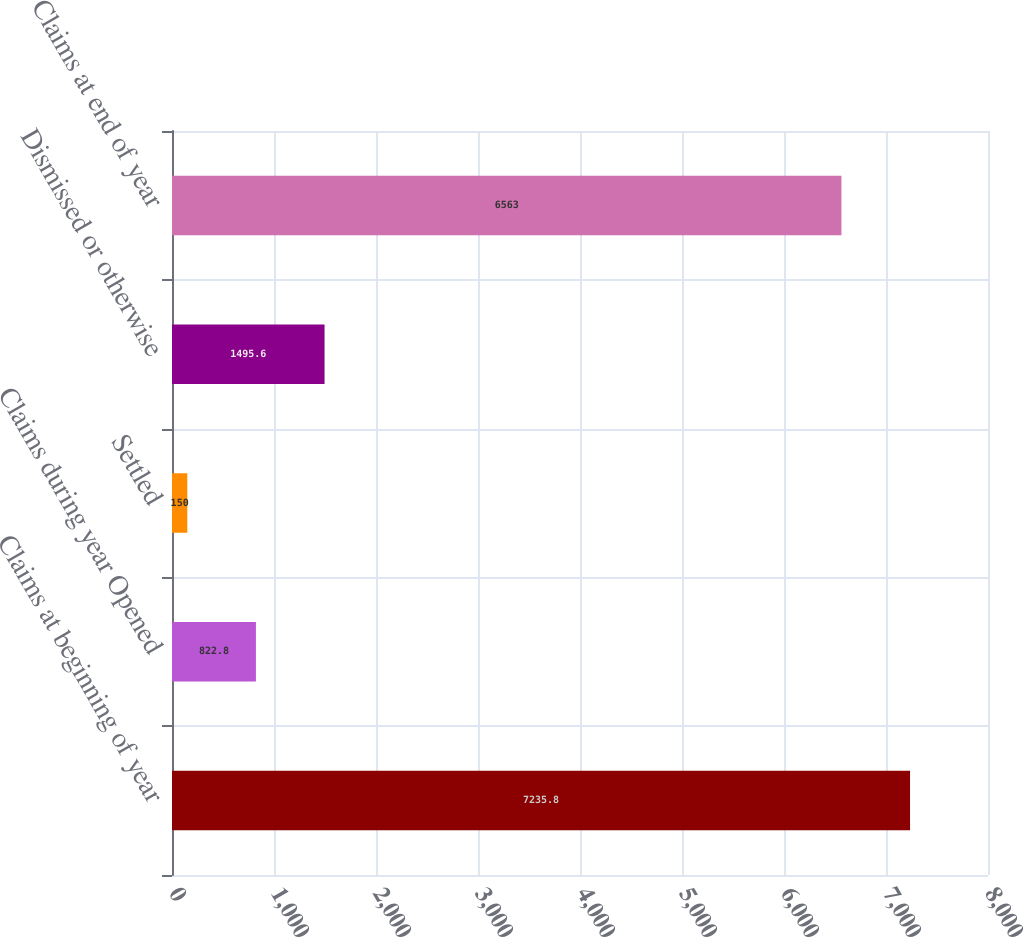<chart> <loc_0><loc_0><loc_500><loc_500><bar_chart><fcel>Claims at beginning of year<fcel>Claims during year Opened<fcel>Settled<fcel>Dismissed or otherwise<fcel>Claims at end of year<nl><fcel>7235.8<fcel>822.8<fcel>150<fcel>1495.6<fcel>6563<nl></chart> 